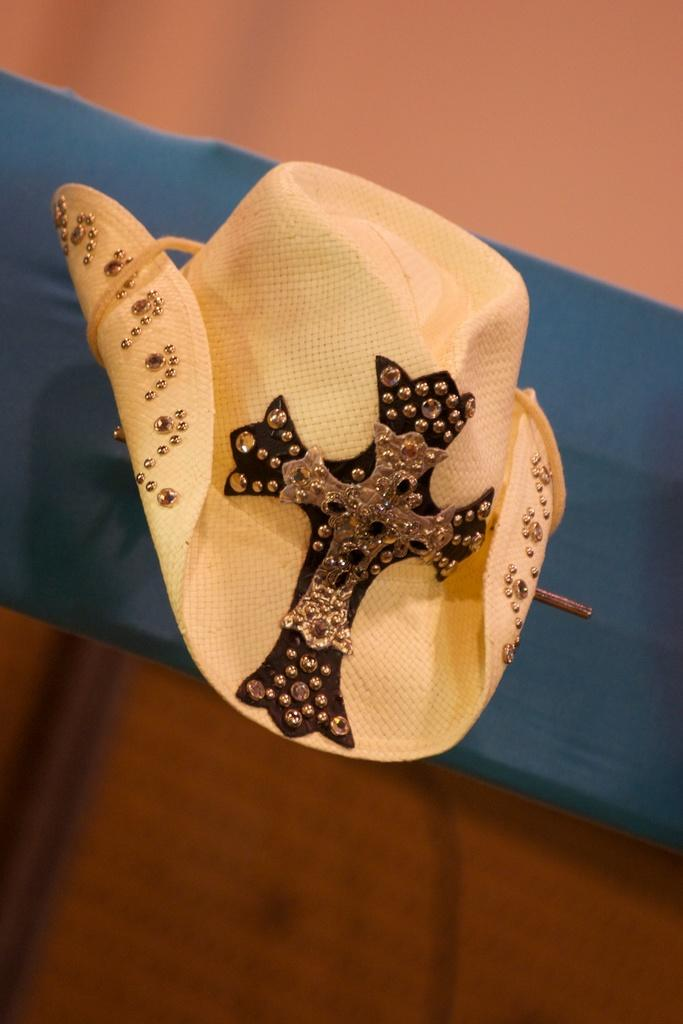What is located in the center of the image? There is cloth and a hat in the center of the image. Can you describe the hat in the image? The hat is located in the center of the image. What is visible in the background of the image? There is a wall in the background of the image. Reasoning: Let' Let's think step by step in order to produce the conversation. We start by identifying the main subjects in the image, which are the cloth and the hat. We then describe the hat in more detail, as it is mentioned twice in the facts. Finally, we mention the wall in the background, which is the only other detail provided about the image. Each question is designed to elicit a specific detail about the image that is known from the provided facts. Absurd Question/Answer: Who is the creator of the knot in the image? There is no knot present in the image, so it is not possible to determine who created it. What type of transport is visible in the image? There is no transport visible in the image; it only features cloth, a hat, and a wall in the background. 